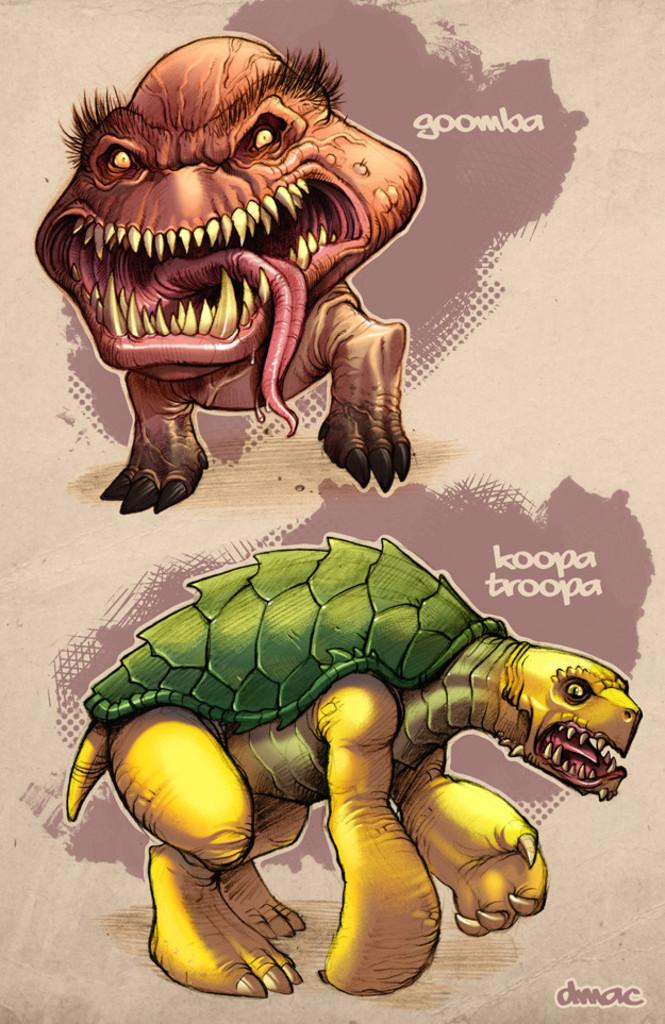What type of pictures can be seen in the image? There are two animated pictures in the image. Can you describe the shape at the bottom of the image? The shape at the bottom of the image resembles a tortoise. What type of quiver is visible in the image? There is no quiver present in the image. What flag is being displayed in the image? There is no flag present in the image. 